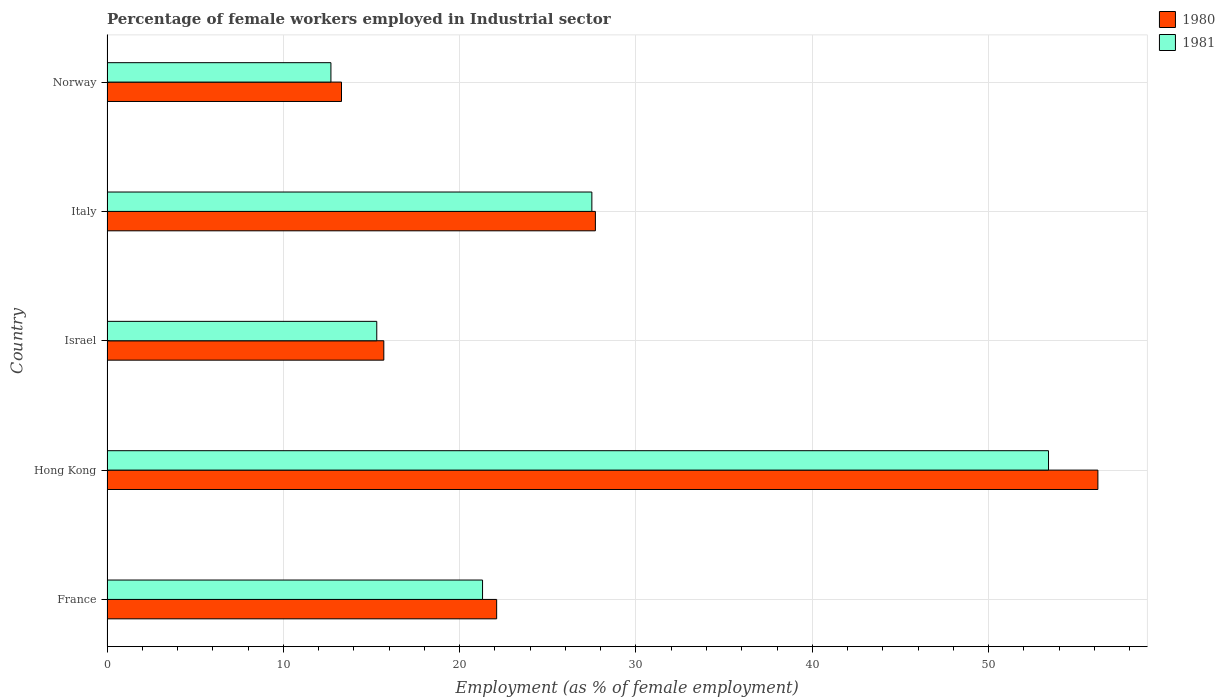How many different coloured bars are there?
Provide a short and direct response. 2. Are the number of bars per tick equal to the number of legend labels?
Your answer should be compact. Yes. Are the number of bars on each tick of the Y-axis equal?
Offer a very short reply. Yes. How many bars are there on the 1st tick from the top?
Provide a short and direct response. 2. How many bars are there on the 5th tick from the bottom?
Provide a short and direct response. 2. What is the label of the 4th group of bars from the top?
Your answer should be compact. Hong Kong. In how many cases, is the number of bars for a given country not equal to the number of legend labels?
Offer a very short reply. 0. What is the percentage of females employed in Industrial sector in 1981 in Norway?
Keep it short and to the point. 12.7. Across all countries, what is the maximum percentage of females employed in Industrial sector in 1981?
Your answer should be very brief. 53.4. Across all countries, what is the minimum percentage of females employed in Industrial sector in 1980?
Make the answer very short. 13.3. In which country was the percentage of females employed in Industrial sector in 1980 maximum?
Keep it short and to the point. Hong Kong. What is the total percentage of females employed in Industrial sector in 1981 in the graph?
Give a very brief answer. 130.2. What is the difference between the percentage of females employed in Industrial sector in 1981 in France and that in Hong Kong?
Your answer should be compact. -32.1. What is the difference between the percentage of females employed in Industrial sector in 1980 in Italy and the percentage of females employed in Industrial sector in 1981 in Norway?
Offer a very short reply. 15. What is the average percentage of females employed in Industrial sector in 1980 per country?
Your answer should be compact. 27. What is the difference between the percentage of females employed in Industrial sector in 1980 and percentage of females employed in Industrial sector in 1981 in Norway?
Give a very brief answer. 0.6. What is the ratio of the percentage of females employed in Industrial sector in 1980 in Hong Kong to that in Israel?
Ensure brevity in your answer.  3.58. Is the difference between the percentage of females employed in Industrial sector in 1980 in France and Israel greater than the difference between the percentage of females employed in Industrial sector in 1981 in France and Israel?
Make the answer very short. Yes. What is the difference between the highest and the second highest percentage of females employed in Industrial sector in 1980?
Your response must be concise. 28.5. What is the difference between the highest and the lowest percentage of females employed in Industrial sector in 1980?
Give a very brief answer. 42.9. Is the sum of the percentage of females employed in Industrial sector in 1981 in France and Hong Kong greater than the maximum percentage of females employed in Industrial sector in 1980 across all countries?
Keep it short and to the point. Yes. What does the 2nd bar from the top in Israel represents?
Offer a terse response. 1980. What does the 1st bar from the bottom in Israel represents?
Ensure brevity in your answer.  1980. How many bars are there?
Offer a very short reply. 10. Are all the bars in the graph horizontal?
Make the answer very short. Yes. What is the difference between two consecutive major ticks on the X-axis?
Provide a short and direct response. 10. Does the graph contain grids?
Make the answer very short. Yes. How many legend labels are there?
Ensure brevity in your answer.  2. How are the legend labels stacked?
Your response must be concise. Vertical. What is the title of the graph?
Offer a terse response. Percentage of female workers employed in Industrial sector. What is the label or title of the X-axis?
Make the answer very short. Employment (as % of female employment). What is the label or title of the Y-axis?
Your response must be concise. Country. What is the Employment (as % of female employment) in 1980 in France?
Provide a succinct answer. 22.1. What is the Employment (as % of female employment) of 1981 in France?
Your answer should be compact. 21.3. What is the Employment (as % of female employment) of 1980 in Hong Kong?
Your answer should be very brief. 56.2. What is the Employment (as % of female employment) of 1981 in Hong Kong?
Offer a terse response. 53.4. What is the Employment (as % of female employment) of 1980 in Israel?
Provide a succinct answer. 15.7. What is the Employment (as % of female employment) of 1981 in Israel?
Your answer should be compact. 15.3. What is the Employment (as % of female employment) in 1980 in Italy?
Give a very brief answer. 27.7. What is the Employment (as % of female employment) of 1981 in Italy?
Your answer should be very brief. 27.5. What is the Employment (as % of female employment) of 1980 in Norway?
Ensure brevity in your answer.  13.3. What is the Employment (as % of female employment) of 1981 in Norway?
Give a very brief answer. 12.7. Across all countries, what is the maximum Employment (as % of female employment) in 1980?
Provide a succinct answer. 56.2. Across all countries, what is the maximum Employment (as % of female employment) of 1981?
Keep it short and to the point. 53.4. Across all countries, what is the minimum Employment (as % of female employment) of 1980?
Make the answer very short. 13.3. Across all countries, what is the minimum Employment (as % of female employment) in 1981?
Your response must be concise. 12.7. What is the total Employment (as % of female employment) in 1980 in the graph?
Provide a short and direct response. 135. What is the total Employment (as % of female employment) of 1981 in the graph?
Provide a succinct answer. 130.2. What is the difference between the Employment (as % of female employment) in 1980 in France and that in Hong Kong?
Your answer should be very brief. -34.1. What is the difference between the Employment (as % of female employment) in 1981 in France and that in Hong Kong?
Give a very brief answer. -32.1. What is the difference between the Employment (as % of female employment) of 1981 in France and that in Italy?
Give a very brief answer. -6.2. What is the difference between the Employment (as % of female employment) in 1980 in Hong Kong and that in Israel?
Make the answer very short. 40.5. What is the difference between the Employment (as % of female employment) in 1981 in Hong Kong and that in Israel?
Provide a short and direct response. 38.1. What is the difference between the Employment (as % of female employment) of 1981 in Hong Kong and that in Italy?
Provide a short and direct response. 25.9. What is the difference between the Employment (as % of female employment) of 1980 in Hong Kong and that in Norway?
Keep it short and to the point. 42.9. What is the difference between the Employment (as % of female employment) of 1981 in Hong Kong and that in Norway?
Make the answer very short. 40.7. What is the difference between the Employment (as % of female employment) in 1981 in Israel and that in Italy?
Offer a very short reply. -12.2. What is the difference between the Employment (as % of female employment) of 1980 in Israel and that in Norway?
Give a very brief answer. 2.4. What is the difference between the Employment (as % of female employment) in 1980 in Italy and that in Norway?
Make the answer very short. 14.4. What is the difference between the Employment (as % of female employment) in 1981 in Italy and that in Norway?
Keep it short and to the point. 14.8. What is the difference between the Employment (as % of female employment) in 1980 in France and the Employment (as % of female employment) in 1981 in Hong Kong?
Offer a terse response. -31.3. What is the difference between the Employment (as % of female employment) of 1980 in Hong Kong and the Employment (as % of female employment) of 1981 in Israel?
Provide a short and direct response. 40.9. What is the difference between the Employment (as % of female employment) in 1980 in Hong Kong and the Employment (as % of female employment) in 1981 in Italy?
Keep it short and to the point. 28.7. What is the difference between the Employment (as % of female employment) in 1980 in Hong Kong and the Employment (as % of female employment) in 1981 in Norway?
Give a very brief answer. 43.5. What is the difference between the Employment (as % of female employment) of 1980 in Israel and the Employment (as % of female employment) of 1981 in Norway?
Your response must be concise. 3. What is the difference between the Employment (as % of female employment) of 1980 in Italy and the Employment (as % of female employment) of 1981 in Norway?
Your answer should be compact. 15. What is the average Employment (as % of female employment) of 1980 per country?
Give a very brief answer. 27. What is the average Employment (as % of female employment) in 1981 per country?
Offer a terse response. 26.04. What is the difference between the Employment (as % of female employment) of 1980 and Employment (as % of female employment) of 1981 in Hong Kong?
Your answer should be compact. 2.8. What is the difference between the Employment (as % of female employment) in 1980 and Employment (as % of female employment) in 1981 in Italy?
Make the answer very short. 0.2. What is the ratio of the Employment (as % of female employment) in 1980 in France to that in Hong Kong?
Give a very brief answer. 0.39. What is the ratio of the Employment (as % of female employment) in 1981 in France to that in Hong Kong?
Offer a terse response. 0.4. What is the ratio of the Employment (as % of female employment) in 1980 in France to that in Israel?
Your answer should be compact. 1.41. What is the ratio of the Employment (as % of female employment) in 1981 in France to that in Israel?
Provide a short and direct response. 1.39. What is the ratio of the Employment (as % of female employment) of 1980 in France to that in Italy?
Provide a succinct answer. 0.8. What is the ratio of the Employment (as % of female employment) in 1981 in France to that in Italy?
Ensure brevity in your answer.  0.77. What is the ratio of the Employment (as % of female employment) in 1980 in France to that in Norway?
Your answer should be very brief. 1.66. What is the ratio of the Employment (as % of female employment) of 1981 in France to that in Norway?
Make the answer very short. 1.68. What is the ratio of the Employment (as % of female employment) in 1980 in Hong Kong to that in Israel?
Your answer should be very brief. 3.58. What is the ratio of the Employment (as % of female employment) in 1981 in Hong Kong to that in Israel?
Make the answer very short. 3.49. What is the ratio of the Employment (as % of female employment) of 1980 in Hong Kong to that in Italy?
Your answer should be very brief. 2.03. What is the ratio of the Employment (as % of female employment) in 1981 in Hong Kong to that in Italy?
Offer a terse response. 1.94. What is the ratio of the Employment (as % of female employment) of 1980 in Hong Kong to that in Norway?
Give a very brief answer. 4.23. What is the ratio of the Employment (as % of female employment) of 1981 in Hong Kong to that in Norway?
Offer a very short reply. 4.2. What is the ratio of the Employment (as % of female employment) in 1980 in Israel to that in Italy?
Offer a very short reply. 0.57. What is the ratio of the Employment (as % of female employment) of 1981 in Israel to that in Italy?
Offer a very short reply. 0.56. What is the ratio of the Employment (as % of female employment) of 1980 in Israel to that in Norway?
Your answer should be compact. 1.18. What is the ratio of the Employment (as % of female employment) in 1981 in Israel to that in Norway?
Give a very brief answer. 1.2. What is the ratio of the Employment (as % of female employment) of 1980 in Italy to that in Norway?
Offer a very short reply. 2.08. What is the ratio of the Employment (as % of female employment) of 1981 in Italy to that in Norway?
Offer a very short reply. 2.17. What is the difference between the highest and the second highest Employment (as % of female employment) in 1981?
Provide a succinct answer. 25.9. What is the difference between the highest and the lowest Employment (as % of female employment) of 1980?
Offer a terse response. 42.9. What is the difference between the highest and the lowest Employment (as % of female employment) in 1981?
Ensure brevity in your answer.  40.7. 